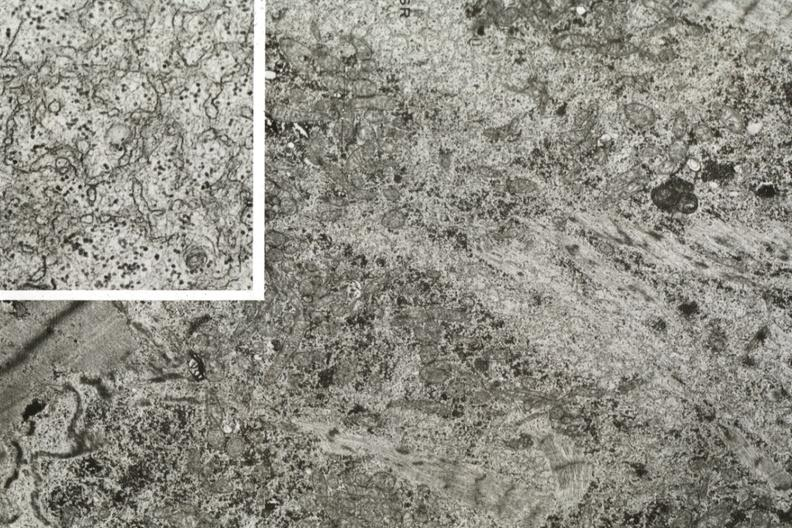does this image show electron micrographs demonstrating marked loss of myofibrils in fiber and inset with dilated sarcoplasmic reticulum?
Answer the question using a single word or phrase. Yes 